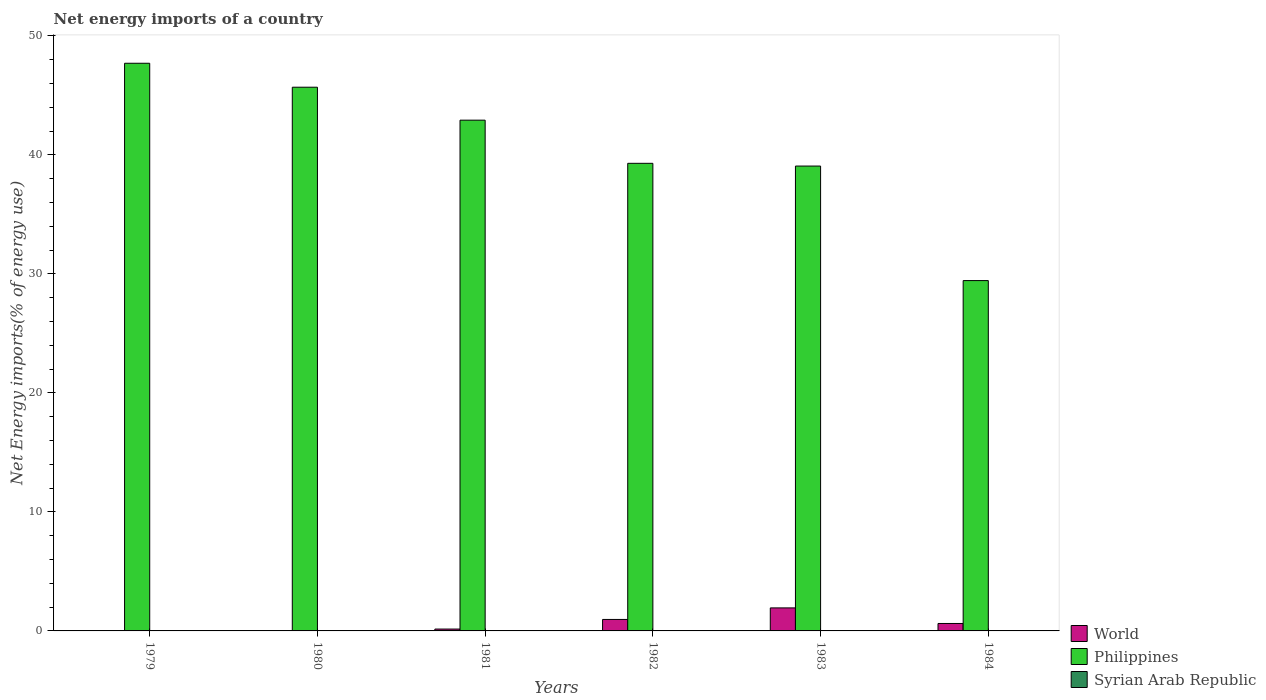How many different coloured bars are there?
Make the answer very short. 2. How many bars are there on the 4th tick from the left?
Ensure brevity in your answer.  2. How many bars are there on the 2nd tick from the right?
Keep it short and to the point. 2. What is the label of the 3rd group of bars from the left?
Your response must be concise. 1981. What is the net energy imports in Philippines in 1984?
Offer a very short reply. 29.44. Across all years, what is the maximum net energy imports in Philippines?
Give a very brief answer. 47.7. Across all years, what is the minimum net energy imports in Philippines?
Your answer should be very brief. 29.44. What is the difference between the net energy imports in Philippines in 1979 and that in 1980?
Provide a succinct answer. 2.01. What is the difference between the net energy imports in World in 1983 and the net energy imports in Syrian Arab Republic in 1984?
Provide a succinct answer. 1.93. What is the average net energy imports in Philippines per year?
Ensure brevity in your answer.  40.68. In the year 1982, what is the difference between the net energy imports in World and net energy imports in Philippines?
Provide a short and direct response. -38.33. What is the ratio of the net energy imports in Philippines in 1982 to that in 1984?
Make the answer very short. 1.33. What is the difference between the highest and the second highest net energy imports in Philippines?
Make the answer very short. 2.01. What is the difference between the highest and the lowest net energy imports in World?
Ensure brevity in your answer.  1.93. Is the sum of the net energy imports in Philippines in 1982 and 1983 greater than the maximum net energy imports in Syrian Arab Republic across all years?
Your response must be concise. Yes. Is it the case that in every year, the sum of the net energy imports in Philippines and net energy imports in Syrian Arab Republic is greater than the net energy imports in World?
Offer a terse response. Yes. Are all the bars in the graph horizontal?
Offer a very short reply. No. How many years are there in the graph?
Offer a very short reply. 6. Does the graph contain grids?
Your answer should be very brief. No. How are the legend labels stacked?
Keep it short and to the point. Vertical. What is the title of the graph?
Keep it short and to the point. Net energy imports of a country. What is the label or title of the X-axis?
Make the answer very short. Years. What is the label or title of the Y-axis?
Give a very brief answer. Net Energy imports(% of energy use). What is the Net Energy imports(% of energy use) of World in 1979?
Your answer should be compact. 0. What is the Net Energy imports(% of energy use) of Philippines in 1979?
Your answer should be compact. 47.7. What is the Net Energy imports(% of energy use) in Philippines in 1980?
Give a very brief answer. 45.69. What is the Net Energy imports(% of energy use) in Syrian Arab Republic in 1980?
Provide a succinct answer. 0. What is the Net Energy imports(% of energy use) in World in 1981?
Offer a terse response. 0.16. What is the Net Energy imports(% of energy use) of Philippines in 1981?
Your answer should be compact. 42.92. What is the Net Energy imports(% of energy use) of Syrian Arab Republic in 1981?
Provide a short and direct response. 0. What is the Net Energy imports(% of energy use) of World in 1982?
Offer a very short reply. 0.96. What is the Net Energy imports(% of energy use) in Philippines in 1982?
Your answer should be compact. 39.29. What is the Net Energy imports(% of energy use) in Syrian Arab Republic in 1982?
Provide a short and direct response. 0. What is the Net Energy imports(% of energy use) in World in 1983?
Provide a succinct answer. 1.93. What is the Net Energy imports(% of energy use) in Philippines in 1983?
Offer a terse response. 39.06. What is the Net Energy imports(% of energy use) in World in 1984?
Your response must be concise. 0.63. What is the Net Energy imports(% of energy use) of Philippines in 1984?
Your answer should be compact. 29.44. Across all years, what is the maximum Net Energy imports(% of energy use) of World?
Keep it short and to the point. 1.93. Across all years, what is the maximum Net Energy imports(% of energy use) in Philippines?
Provide a short and direct response. 47.7. Across all years, what is the minimum Net Energy imports(% of energy use) in World?
Ensure brevity in your answer.  0. Across all years, what is the minimum Net Energy imports(% of energy use) in Philippines?
Keep it short and to the point. 29.44. What is the total Net Energy imports(% of energy use) of World in the graph?
Offer a very short reply. 3.68. What is the total Net Energy imports(% of energy use) of Philippines in the graph?
Offer a very short reply. 244.1. What is the difference between the Net Energy imports(% of energy use) in Philippines in 1979 and that in 1980?
Provide a short and direct response. 2.01. What is the difference between the Net Energy imports(% of energy use) in Philippines in 1979 and that in 1981?
Offer a terse response. 4.78. What is the difference between the Net Energy imports(% of energy use) of Philippines in 1979 and that in 1982?
Give a very brief answer. 8.41. What is the difference between the Net Energy imports(% of energy use) of Philippines in 1979 and that in 1983?
Your response must be concise. 8.64. What is the difference between the Net Energy imports(% of energy use) of Philippines in 1979 and that in 1984?
Keep it short and to the point. 18.26. What is the difference between the Net Energy imports(% of energy use) of Philippines in 1980 and that in 1981?
Provide a short and direct response. 2.77. What is the difference between the Net Energy imports(% of energy use) of Philippines in 1980 and that in 1982?
Ensure brevity in your answer.  6.4. What is the difference between the Net Energy imports(% of energy use) in Philippines in 1980 and that in 1983?
Make the answer very short. 6.63. What is the difference between the Net Energy imports(% of energy use) in Philippines in 1980 and that in 1984?
Keep it short and to the point. 16.25. What is the difference between the Net Energy imports(% of energy use) in World in 1981 and that in 1982?
Ensure brevity in your answer.  -0.81. What is the difference between the Net Energy imports(% of energy use) in Philippines in 1981 and that in 1982?
Give a very brief answer. 3.63. What is the difference between the Net Energy imports(% of energy use) of World in 1981 and that in 1983?
Offer a very short reply. -1.78. What is the difference between the Net Energy imports(% of energy use) of Philippines in 1981 and that in 1983?
Make the answer very short. 3.86. What is the difference between the Net Energy imports(% of energy use) of World in 1981 and that in 1984?
Your answer should be very brief. -0.47. What is the difference between the Net Energy imports(% of energy use) of Philippines in 1981 and that in 1984?
Your answer should be very brief. 13.48. What is the difference between the Net Energy imports(% of energy use) of World in 1982 and that in 1983?
Your answer should be very brief. -0.97. What is the difference between the Net Energy imports(% of energy use) of Philippines in 1982 and that in 1983?
Make the answer very short. 0.23. What is the difference between the Net Energy imports(% of energy use) of World in 1982 and that in 1984?
Provide a short and direct response. 0.34. What is the difference between the Net Energy imports(% of energy use) of Philippines in 1982 and that in 1984?
Your answer should be compact. 9.85. What is the difference between the Net Energy imports(% of energy use) in World in 1983 and that in 1984?
Offer a very short reply. 1.31. What is the difference between the Net Energy imports(% of energy use) of Philippines in 1983 and that in 1984?
Make the answer very short. 9.62. What is the difference between the Net Energy imports(% of energy use) in World in 1981 and the Net Energy imports(% of energy use) in Philippines in 1982?
Make the answer very short. -39.14. What is the difference between the Net Energy imports(% of energy use) in World in 1981 and the Net Energy imports(% of energy use) in Philippines in 1983?
Ensure brevity in your answer.  -38.91. What is the difference between the Net Energy imports(% of energy use) of World in 1981 and the Net Energy imports(% of energy use) of Philippines in 1984?
Your answer should be compact. -29.28. What is the difference between the Net Energy imports(% of energy use) in World in 1982 and the Net Energy imports(% of energy use) in Philippines in 1983?
Make the answer very short. -38.1. What is the difference between the Net Energy imports(% of energy use) in World in 1982 and the Net Energy imports(% of energy use) in Philippines in 1984?
Offer a terse response. -28.47. What is the difference between the Net Energy imports(% of energy use) of World in 1983 and the Net Energy imports(% of energy use) of Philippines in 1984?
Keep it short and to the point. -27.5. What is the average Net Energy imports(% of energy use) in World per year?
Ensure brevity in your answer.  0.61. What is the average Net Energy imports(% of energy use) of Philippines per year?
Keep it short and to the point. 40.68. What is the average Net Energy imports(% of energy use) in Syrian Arab Republic per year?
Offer a terse response. 0. In the year 1981, what is the difference between the Net Energy imports(% of energy use) in World and Net Energy imports(% of energy use) in Philippines?
Give a very brief answer. -42.76. In the year 1982, what is the difference between the Net Energy imports(% of energy use) in World and Net Energy imports(% of energy use) in Philippines?
Your answer should be very brief. -38.33. In the year 1983, what is the difference between the Net Energy imports(% of energy use) of World and Net Energy imports(% of energy use) of Philippines?
Your response must be concise. -37.13. In the year 1984, what is the difference between the Net Energy imports(% of energy use) of World and Net Energy imports(% of energy use) of Philippines?
Give a very brief answer. -28.81. What is the ratio of the Net Energy imports(% of energy use) in Philippines in 1979 to that in 1980?
Your answer should be compact. 1.04. What is the ratio of the Net Energy imports(% of energy use) in Philippines in 1979 to that in 1981?
Make the answer very short. 1.11. What is the ratio of the Net Energy imports(% of energy use) in Philippines in 1979 to that in 1982?
Give a very brief answer. 1.21. What is the ratio of the Net Energy imports(% of energy use) of Philippines in 1979 to that in 1983?
Provide a short and direct response. 1.22. What is the ratio of the Net Energy imports(% of energy use) in Philippines in 1979 to that in 1984?
Offer a terse response. 1.62. What is the ratio of the Net Energy imports(% of energy use) in Philippines in 1980 to that in 1981?
Offer a very short reply. 1.06. What is the ratio of the Net Energy imports(% of energy use) in Philippines in 1980 to that in 1982?
Your answer should be compact. 1.16. What is the ratio of the Net Energy imports(% of energy use) of Philippines in 1980 to that in 1983?
Provide a short and direct response. 1.17. What is the ratio of the Net Energy imports(% of energy use) in Philippines in 1980 to that in 1984?
Provide a short and direct response. 1.55. What is the ratio of the Net Energy imports(% of energy use) of World in 1981 to that in 1982?
Offer a very short reply. 0.16. What is the ratio of the Net Energy imports(% of energy use) of Philippines in 1981 to that in 1982?
Keep it short and to the point. 1.09. What is the ratio of the Net Energy imports(% of energy use) in World in 1981 to that in 1983?
Provide a succinct answer. 0.08. What is the ratio of the Net Energy imports(% of energy use) in Philippines in 1981 to that in 1983?
Offer a very short reply. 1.1. What is the ratio of the Net Energy imports(% of energy use) of World in 1981 to that in 1984?
Offer a very short reply. 0.25. What is the ratio of the Net Energy imports(% of energy use) of Philippines in 1981 to that in 1984?
Provide a short and direct response. 1.46. What is the ratio of the Net Energy imports(% of energy use) in World in 1982 to that in 1983?
Give a very brief answer. 0.5. What is the ratio of the Net Energy imports(% of energy use) of Philippines in 1982 to that in 1983?
Offer a terse response. 1.01. What is the ratio of the Net Energy imports(% of energy use) in World in 1982 to that in 1984?
Provide a succinct answer. 1.54. What is the ratio of the Net Energy imports(% of energy use) in Philippines in 1982 to that in 1984?
Provide a succinct answer. 1.33. What is the ratio of the Net Energy imports(% of energy use) in World in 1983 to that in 1984?
Provide a succinct answer. 3.09. What is the ratio of the Net Energy imports(% of energy use) of Philippines in 1983 to that in 1984?
Make the answer very short. 1.33. What is the difference between the highest and the second highest Net Energy imports(% of energy use) in World?
Your answer should be very brief. 0.97. What is the difference between the highest and the second highest Net Energy imports(% of energy use) of Philippines?
Give a very brief answer. 2.01. What is the difference between the highest and the lowest Net Energy imports(% of energy use) of World?
Provide a short and direct response. 1.94. What is the difference between the highest and the lowest Net Energy imports(% of energy use) of Philippines?
Your answer should be very brief. 18.26. 